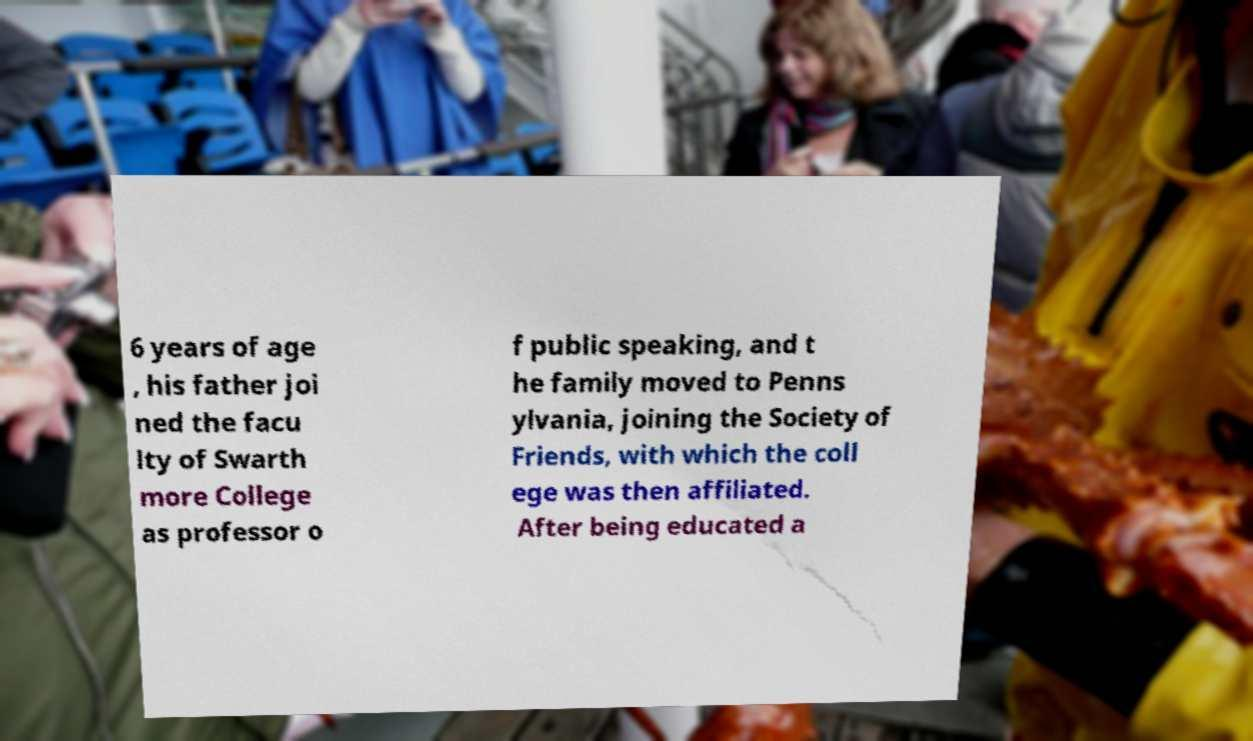For documentation purposes, I need the text within this image transcribed. Could you provide that? 6 years of age , his father joi ned the facu lty of Swarth more College as professor o f public speaking, and t he family moved to Penns ylvania, joining the Society of Friends, with which the coll ege was then affiliated. After being educated a 